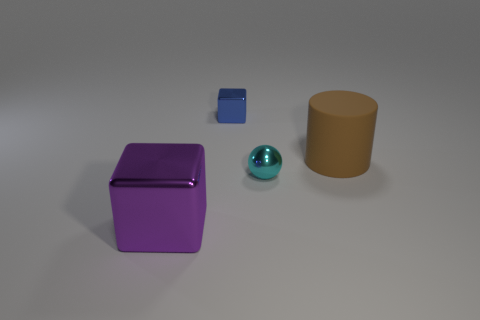Add 1 big yellow shiny cylinders. How many objects exist? 5 Subtract all purple blocks. How many blocks are left? 1 Subtract all spheres. How many objects are left? 3 Subtract 0 brown balls. How many objects are left? 4 Subtract all red balls. Subtract all gray cylinders. How many balls are left? 1 Subtract all green balls. How many yellow cylinders are left? 0 Subtract all large blue matte balls. Subtract all tiny blocks. How many objects are left? 3 Add 2 big shiny blocks. How many big shiny blocks are left? 3 Add 3 shiny objects. How many shiny objects exist? 6 